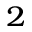<formula> <loc_0><loc_0><loc_500><loc_500>^ { 2 }</formula> 